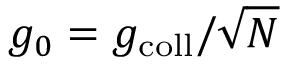<formula> <loc_0><loc_0><loc_500><loc_500>g _ { 0 } = g _ { c o l l } / \sqrt { N }</formula> 